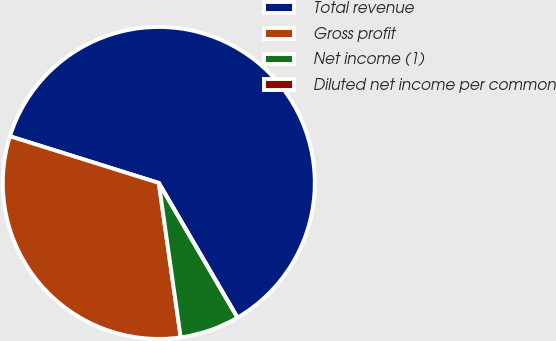Convert chart. <chart><loc_0><loc_0><loc_500><loc_500><pie_chart><fcel>Total revenue<fcel>Gross profit<fcel>Net income (1)<fcel>Diluted net income per common<nl><fcel>61.75%<fcel>32.08%<fcel>6.17%<fcel>0.0%<nl></chart> 